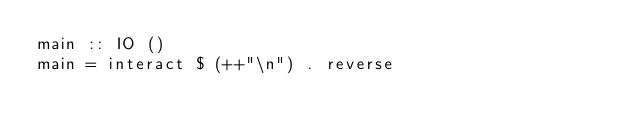<code> <loc_0><loc_0><loc_500><loc_500><_Haskell_>main :: IO ()
main = interact $ (++"\n") . reverse</code> 